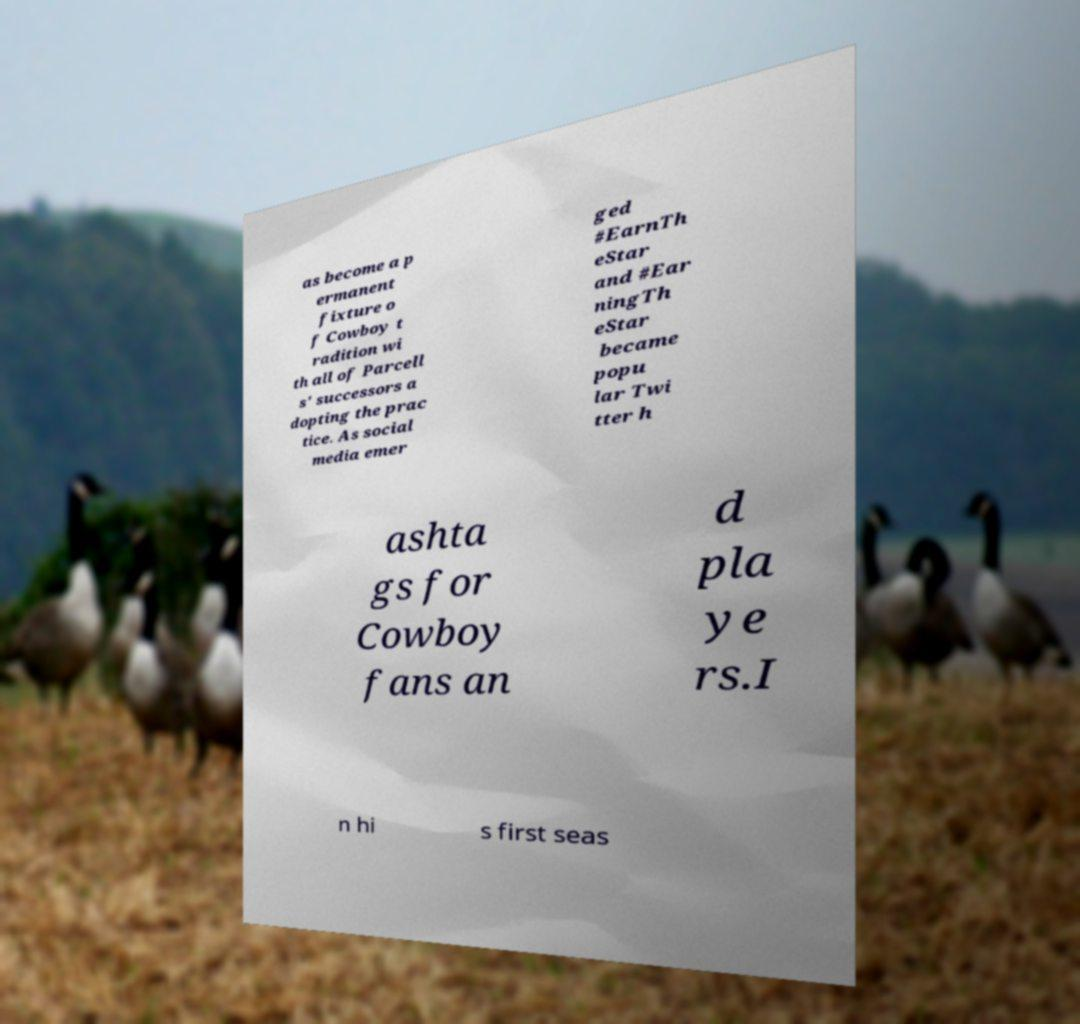For documentation purposes, I need the text within this image transcribed. Could you provide that? as become a p ermanent fixture o f Cowboy t radition wi th all of Parcell s' successors a dopting the prac tice. As social media emer ged #EarnTh eStar and #Ear ningTh eStar became popu lar Twi tter h ashta gs for Cowboy fans an d pla ye rs.I n hi s first seas 